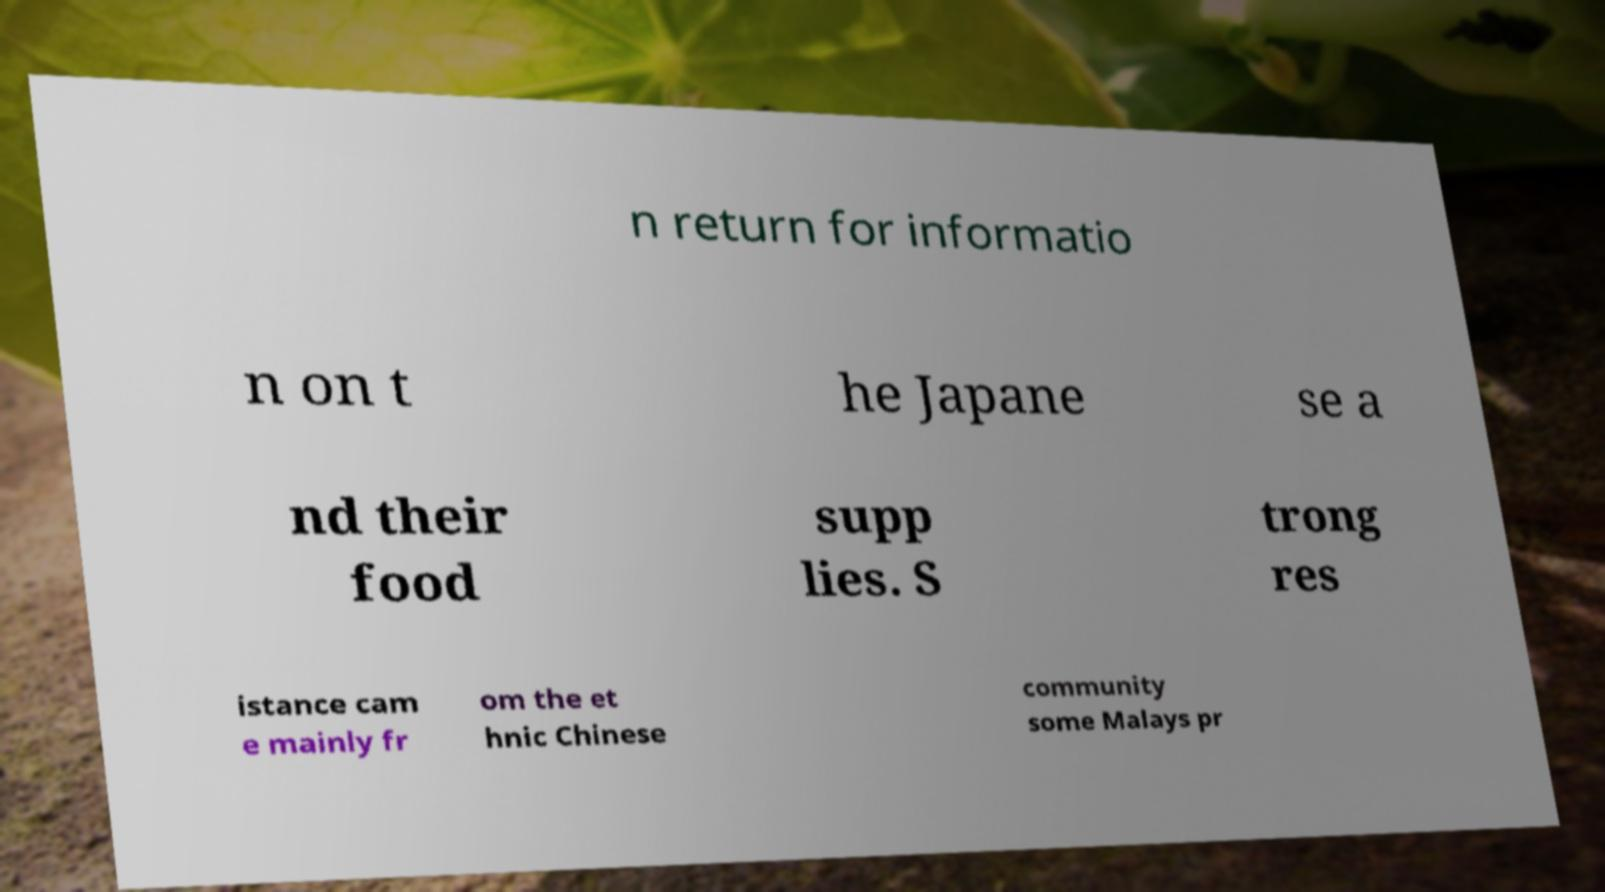Please read and relay the text visible in this image. What does it say? n return for informatio n on t he Japane se a nd their food supp lies. S trong res istance cam e mainly fr om the et hnic Chinese community some Malays pr 